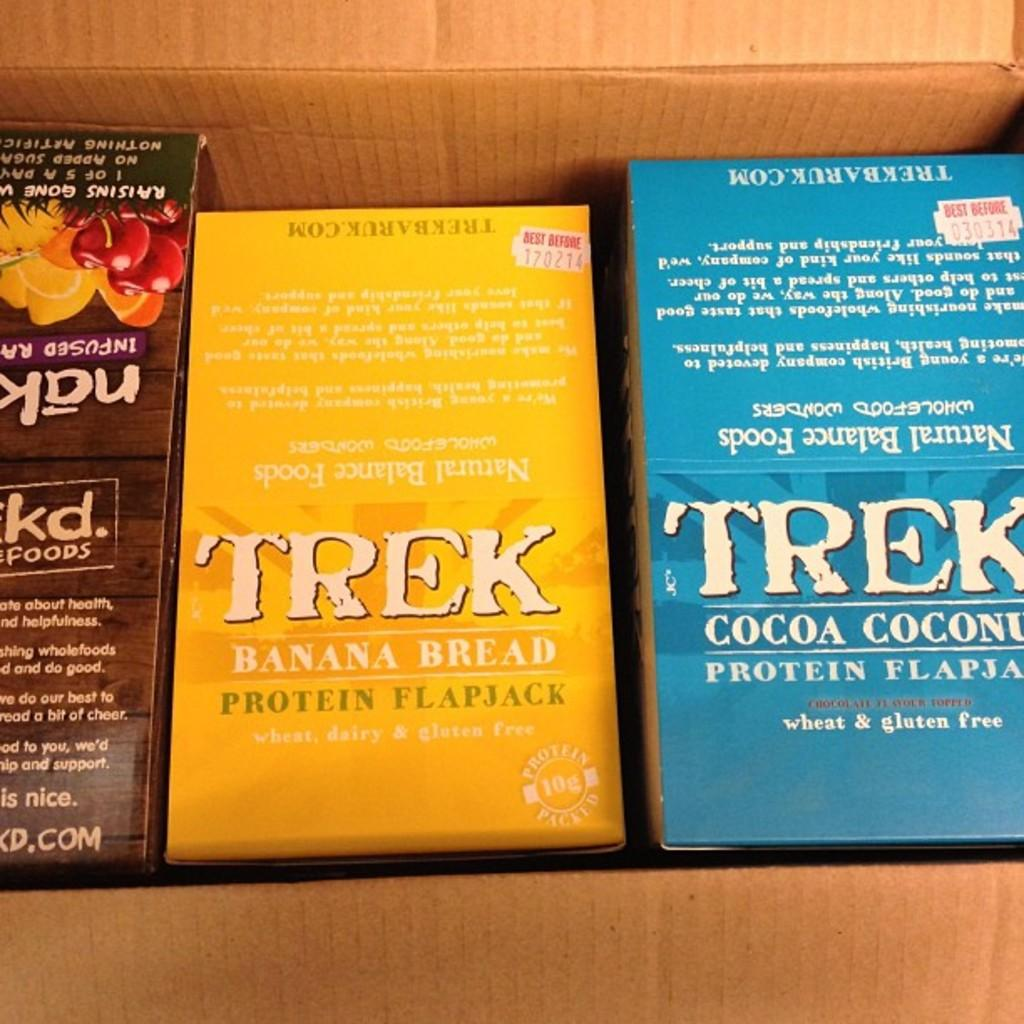<image>
Describe the image concisely. a book that is by trek, callled 'banana bread' 